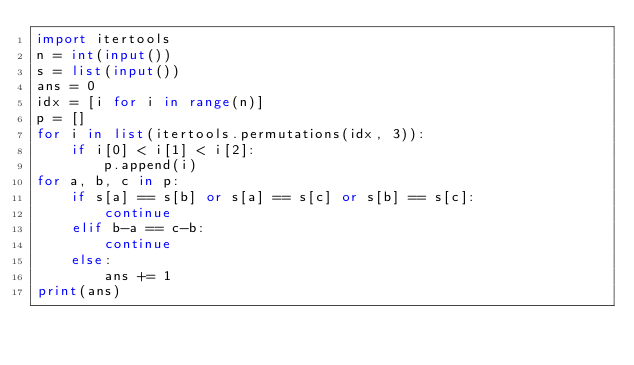<code> <loc_0><loc_0><loc_500><loc_500><_Python_>import itertools
n = int(input())
s = list(input())
ans = 0
idx = [i for i in range(n)]
p = []
for i in list(itertools.permutations(idx, 3)):
    if i[0] < i[1] < i[2]:
        p.append(i)
for a, b, c in p:
    if s[a] == s[b] or s[a] == s[c] or s[b] == s[c]:
        continue
    elif b-a == c-b:
        continue
    else:
        ans += 1
print(ans)</code> 